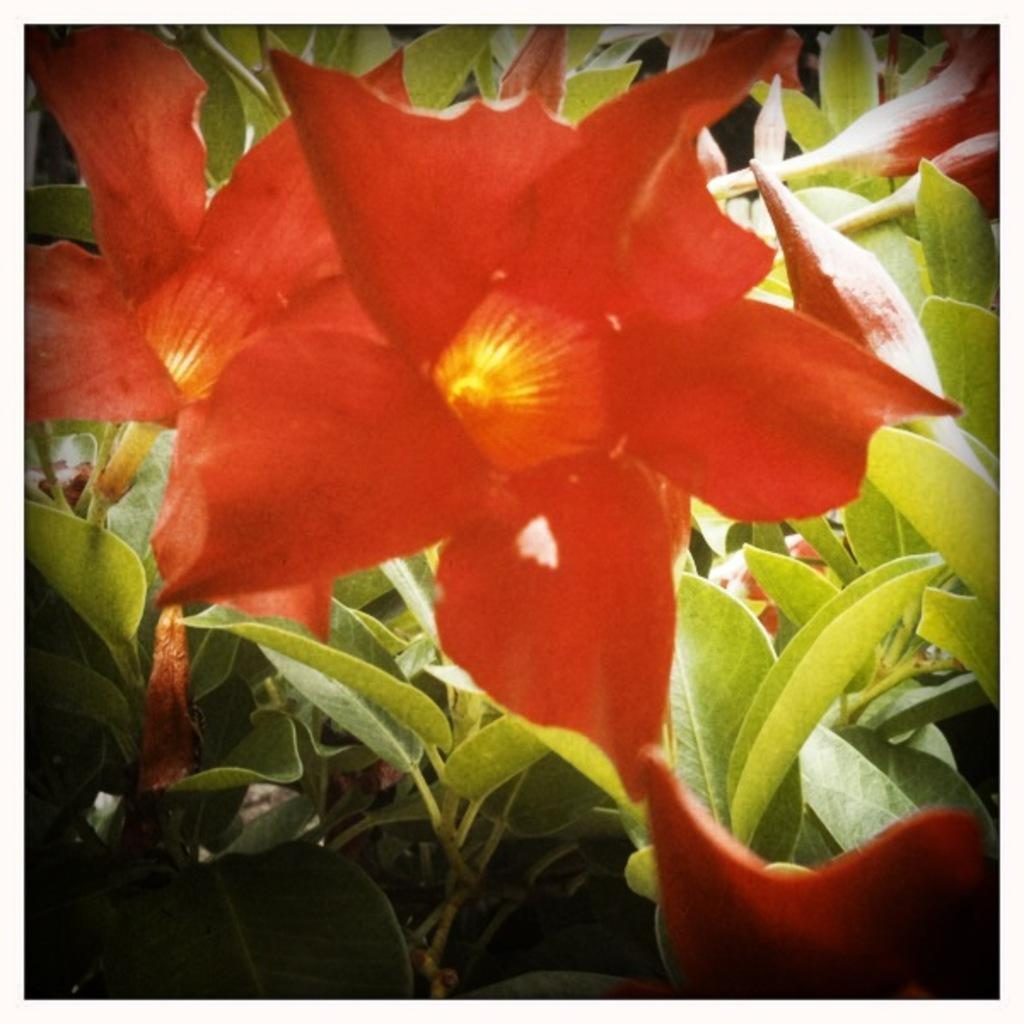What type of flowers are in the foreground of the image? There are red flowers in the foreground of the image. What can be seen in the background of the image? There are leaves in the background of the image. What type of hope can be seen in the image? There is no reference to hope in the image; it features red flowers in the foreground and leaves in the background. 